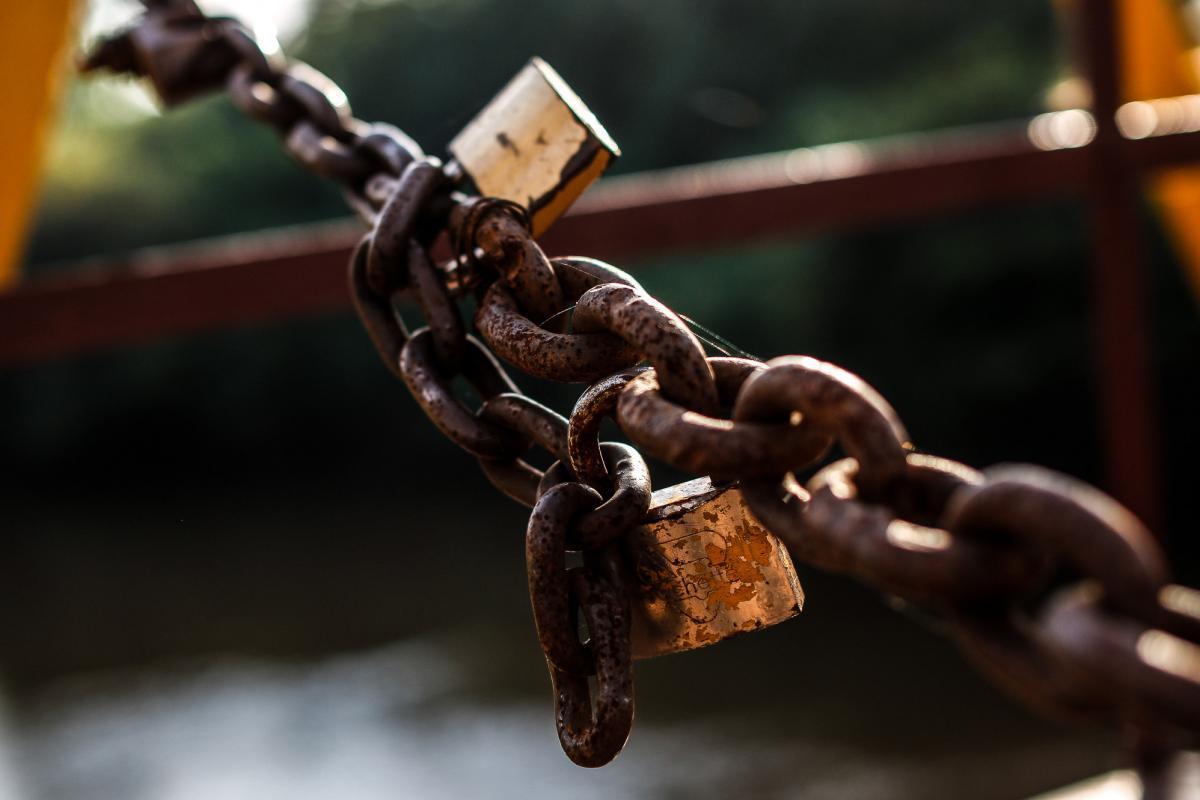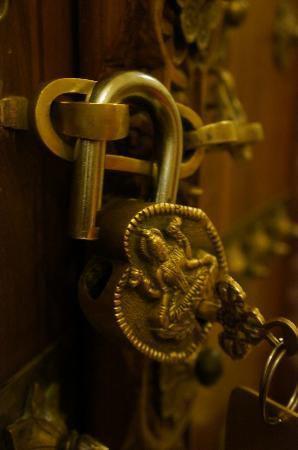The first image is the image on the left, the second image is the image on the right. Assess this claim about the two images: "An image shows a rusty brownish chain attached to at least one lock, in front of brownish bars.". Correct or not? Answer yes or no. Yes. The first image is the image on the left, the second image is the image on the right. Evaluate the accuracy of this statement regarding the images: "A lock is hanging on a chain in the image on the left.". Is it true? Answer yes or no. Yes. 